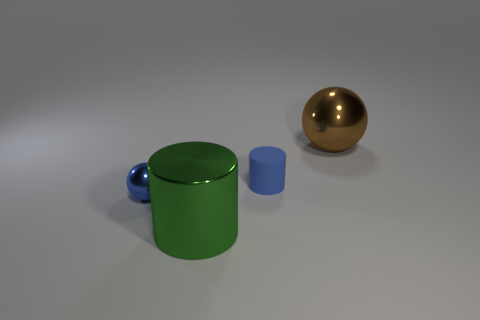Add 2 blue matte cylinders. How many blue matte cylinders are left? 3 Add 2 red cubes. How many red cubes exist? 2 Add 1 large green metal cylinders. How many objects exist? 5 Subtract all blue spheres. How many spheres are left? 1 Subtract 1 green cylinders. How many objects are left? 3 Subtract 2 cylinders. How many cylinders are left? 0 Subtract all yellow spheres. Subtract all green blocks. How many spheres are left? 2 Subtract all cyan cylinders. How many brown spheres are left? 1 Subtract all metal objects. Subtract all yellow metallic things. How many objects are left? 1 